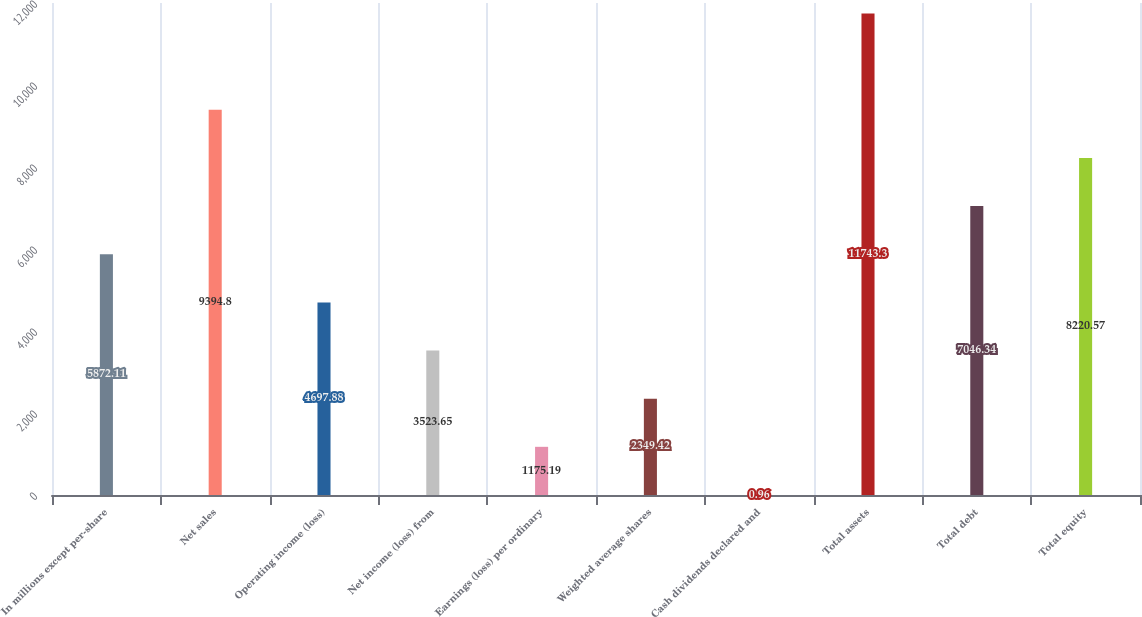<chart> <loc_0><loc_0><loc_500><loc_500><bar_chart><fcel>In millions except per-share<fcel>Net sales<fcel>Operating income (loss)<fcel>Net income (loss) from<fcel>Earnings (loss) per ordinary<fcel>Weighted average shares<fcel>Cash dividends declared and<fcel>Total assets<fcel>Total debt<fcel>Total equity<nl><fcel>5872.11<fcel>9394.8<fcel>4697.88<fcel>3523.65<fcel>1175.19<fcel>2349.42<fcel>0.96<fcel>11743.3<fcel>7046.34<fcel>8220.57<nl></chart> 